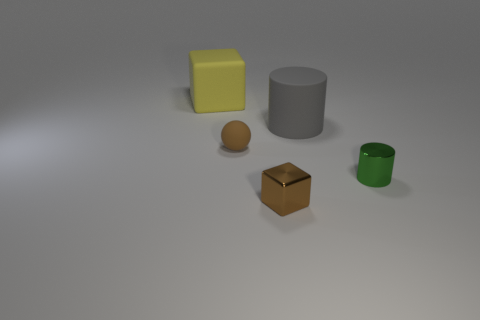Add 4 small matte things. How many objects exist? 9 Subtract all gray cylinders. How many cylinders are left? 1 Subtract 1 cylinders. How many cylinders are left? 1 Subtract 0 green blocks. How many objects are left? 5 Subtract all spheres. How many objects are left? 4 Subtract all green cylinders. Subtract all gray blocks. How many cylinders are left? 1 Subtract all small shiny cubes. Subtract all metal cubes. How many objects are left? 3 Add 5 brown balls. How many brown balls are left? 6 Add 5 large gray matte cylinders. How many large gray matte cylinders exist? 6 